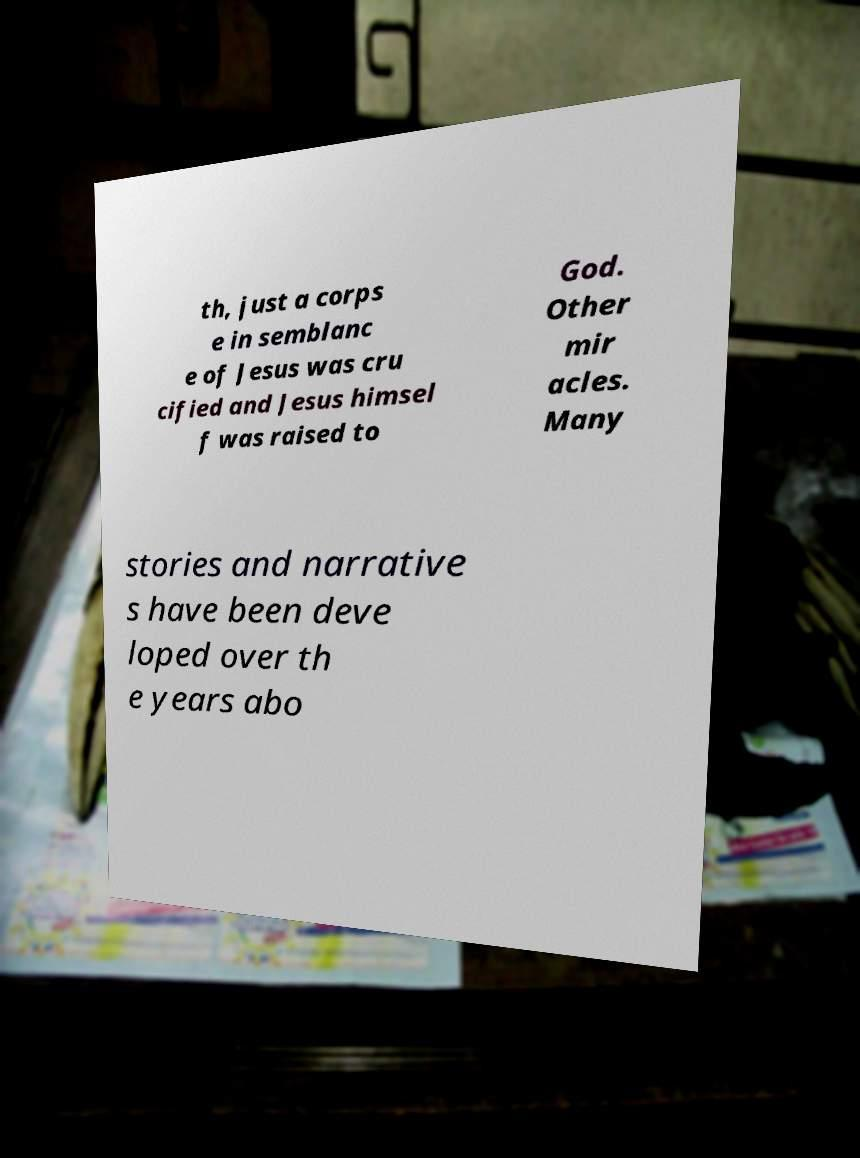Please identify and transcribe the text found in this image. th, just a corps e in semblanc e of Jesus was cru cified and Jesus himsel f was raised to God. Other mir acles. Many stories and narrative s have been deve loped over th e years abo 